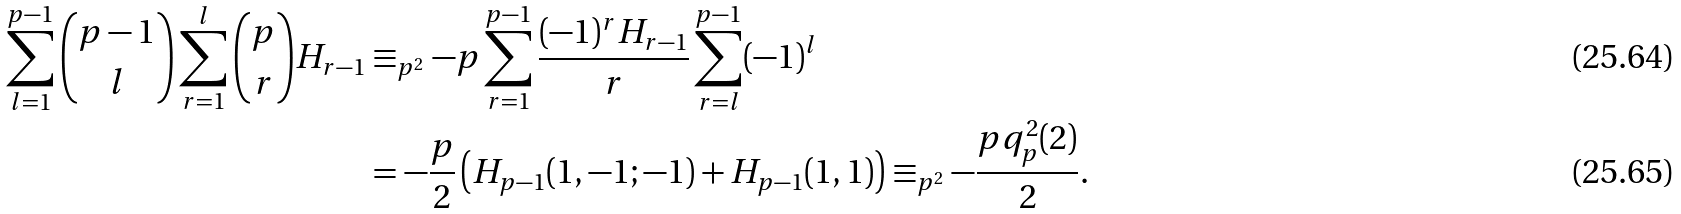<formula> <loc_0><loc_0><loc_500><loc_500>\sum _ { l = 1 } ^ { p - 1 } \binom { p - 1 } { l } \sum _ { r = 1 } ^ { l } \binom { p } { r } H _ { r - 1 } & \equiv _ { p ^ { 2 } } - p \sum _ { r = 1 } ^ { p - 1 } \frac { ( - 1 ) ^ { r } H _ { r - 1 } } { r } \sum _ { r = l } ^ { p - 1 } ( - 1 ) ^ { l } \\ & = - \frac { p } { 2 } \left ( H _ { p - 1 } ( 1 , - 1 ; - 1 ) + H _ { p - 1 } ( 1 , 1 ) \right ) \equiv _ { p ^ { 2 } } - \frac { p q _ { p } ^ { 2 } ( 2 ) } { 2 } .</formula> 